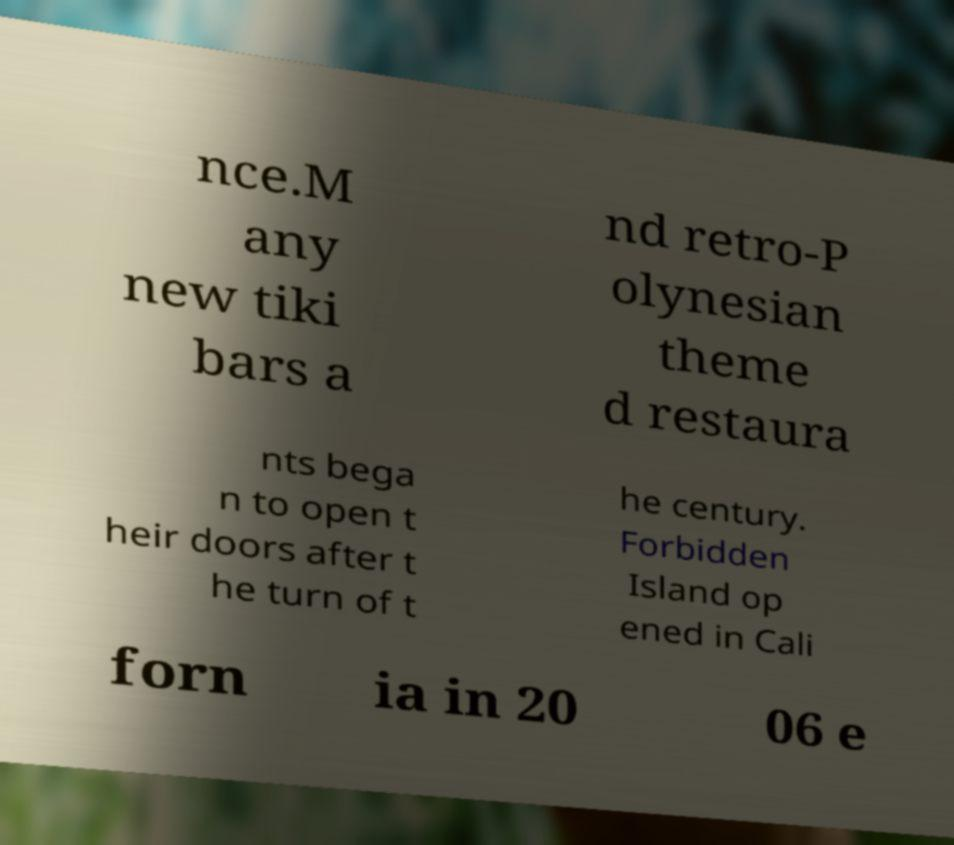Please identify and transcribe the text found in this image. nce.M any new tiki bars a nd retro-P olynesian theme d restaura nts bega n to open t heir doors after t he turn of t he century. Forbidden Island op ened in Cali forn ia in 20 06 e 